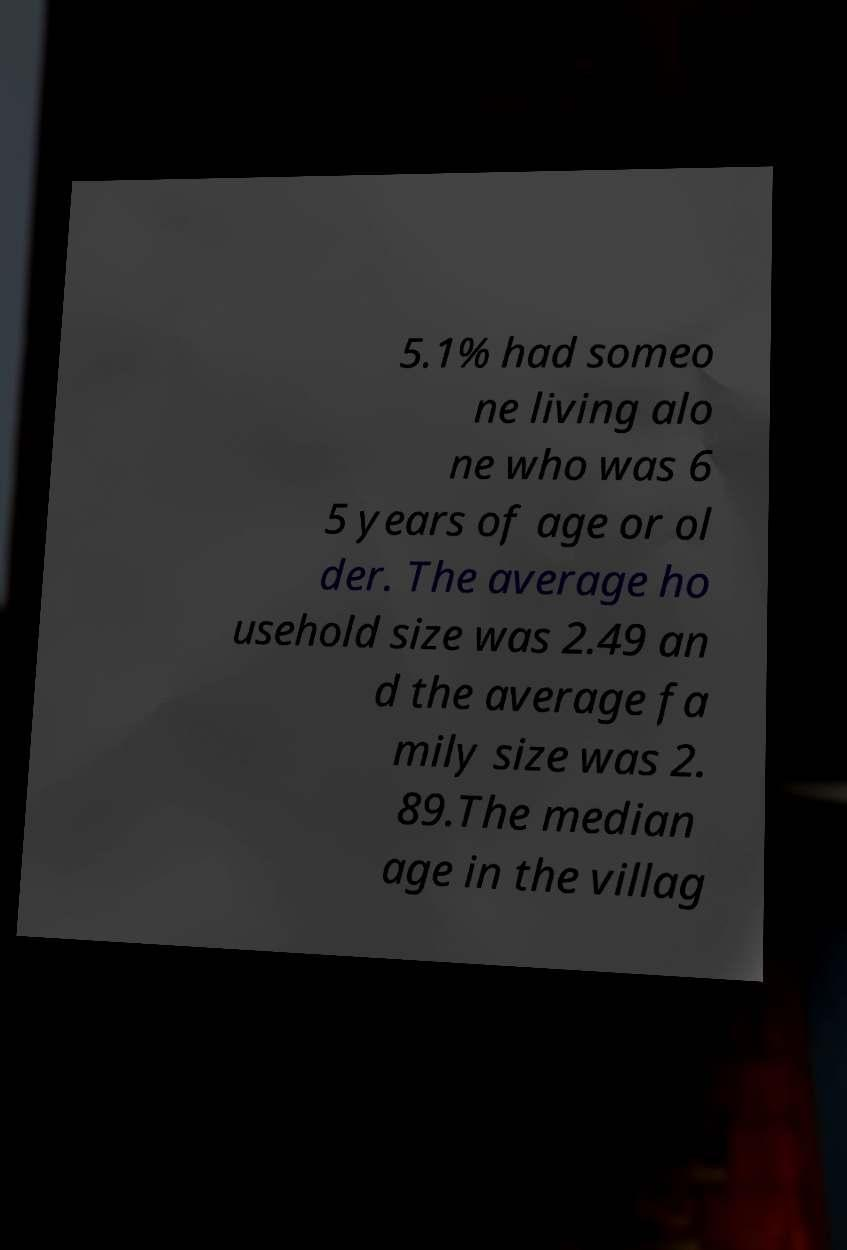Could you assist in decoding the text presented in this image and type it out clearly? 5.1% had someo ne living alo ne who was 6 5 years of age or ol der. The average ho usehold size was 2.49 an d the average fa mily size was 2. 89.The median age in the villag 